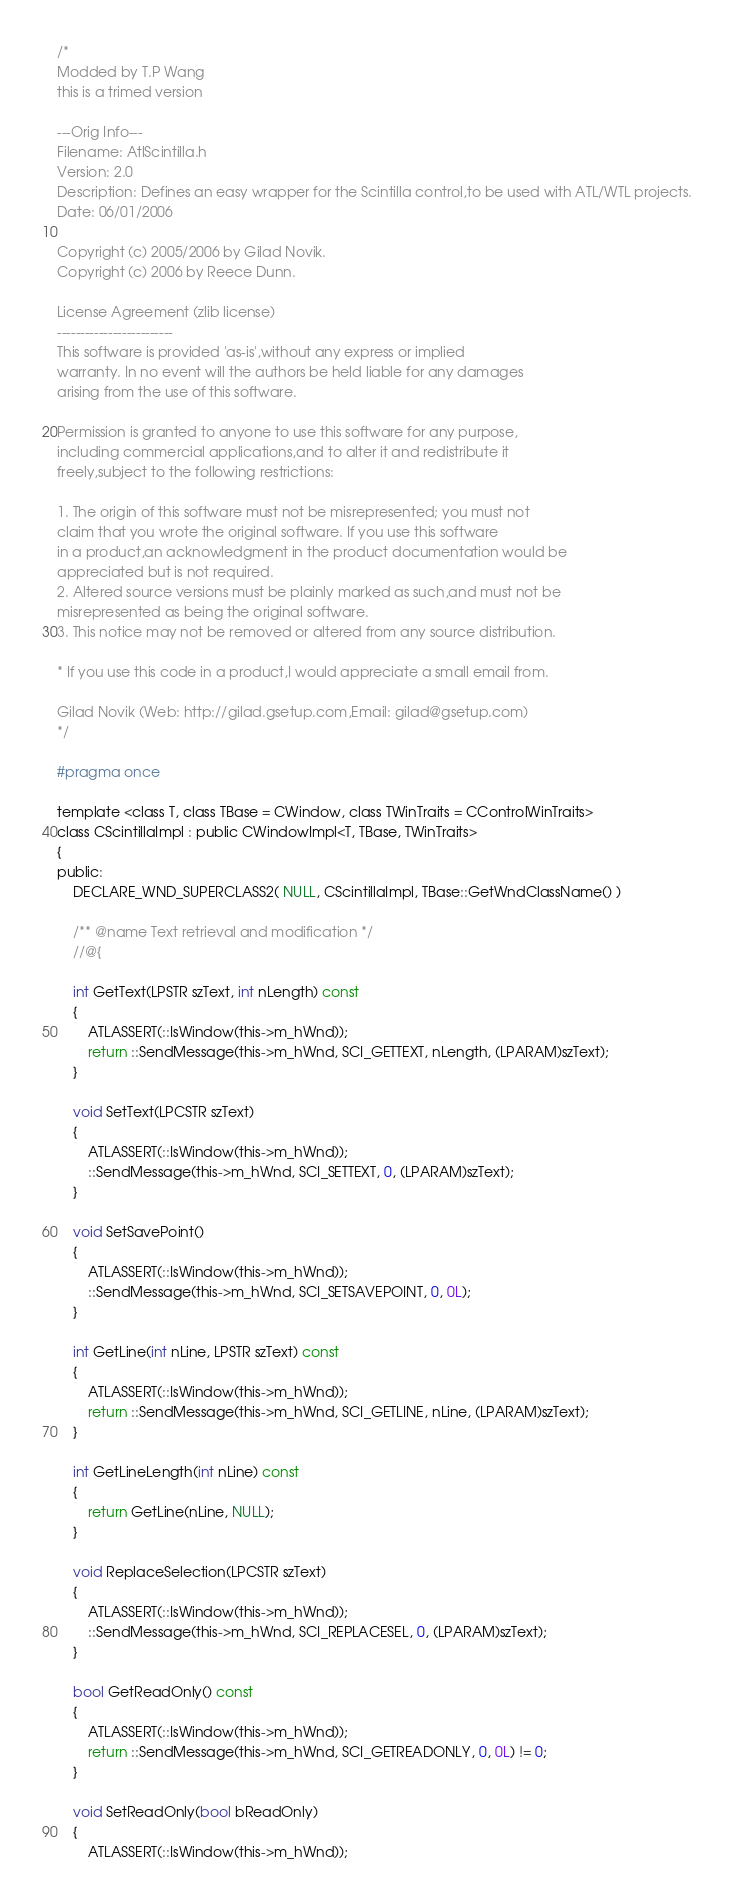Convert code to text. <code><loc_0><loc_0><loc_500><loc_500><_C_>/*
Modded by T.P Wang
this is a trimed version

---Orig Info---
Filename: AtlScintilla.h
Version: 2.0
Description: Defines an easy wrapper for the Scintilla control,to be used with ATL/WTL projects.
Date: 06/01/2006

Copyright (c) 2005/2006 by Gilad Novik.
Copyright (c) 2006 by Reece Dunn.

License Agreement (zlib license)
-------------------------
This software is provided 'as-is',without any express or implied
warranty. In no event will the authors be held liable for any damages
arising from the use of this software.

Permission is granted to anyone to use this software for any purpose,
including commercial applications,and to alter it and redistribute it
freely,subject to the following restrictions:

1. The origin of this software must not be misrepresented; you must not
claim that you wrote the original software. If you use this software
in a product,an acknowledgment in the product documentation would be
appreciated but is not required.
2. Altered source versions must be plainly marked as such,and must not be
misrepresented as being the original software.
3. This notice may not be removed or altered from any source distribution.

* If you use this code in a product,I would appreciate a small email from.

Gilad Novik (Web: http://gilad.gsetup.com,Email: gilad@gsetup.com)
*/

#pragma once

template <class T, class TBase = CWindow, class TWinTraits = CControlWinTraits>
class CScintillaImpl : public CWindowImpl<T, TBase, TWinTraits>
{
public:
    DECLARE_WND_SUPERCLASS2( NULL, CScintillaImpl, TBase::GetWndClassName() )

	/** @name Text retrieval and modification */
	//@{

	int GetText(LPSTR szText, int nLength) const
	{
		ATLASSERT(::IsWindow(this->m_hWnd));
		return ::SendMessage(this->m_hWnd, SCI_GETTEXT, nLength, (LPARAM)szText);
	}

	void SetText(LPCSTR szText)
	{
		ATLASSERT(::IsWindow(this->m_hWnd));
		::SendMessage(this->m_hWnd, SCI_SETTEXT, 0, (LPARAM)szText);
	}

	void SetSavePoint()
	{
		ATLASSERT(::IsWindow(this->m_hWnd));
		::SendMessage(this->m_hWnd, SCI_SETSAVEPOINT, 0, 0L);
	}

	int GetLine(int nLine, LPSTR szText) const
	{
		ATLASSERT(::IsWindow(this->m_hWnd));
		return ::SendMessage(this->m_hWnd, SCI_GETLINE, nLine, (LPARAM)szText);
	}

	int GetLineLength(int nLine) const
	{
		return GetLine(nLine, NULL);
	}

	void ReplaceSelection(LPCSTR szText)
	{
		ATLASSERT(::IsWindow(this->m_hWnd));
		::SendMessage(this->m_hWnd, SCI_REPLACESEL, 0, (LPARAM)szText);
	}

	bool GetReadOnly() const
	{
		ATLASSERT(::IsWindow(this->m_hWnd));
		return ::SendMessage(this->m_hWnd, SCI_GETREADONLY, 0, 0L) != 0;
	}

	void SetReadOnly(bool bReadOnly)
	{
		ATLASSERT(::IsWindow(this->m_hWnd));</code> 